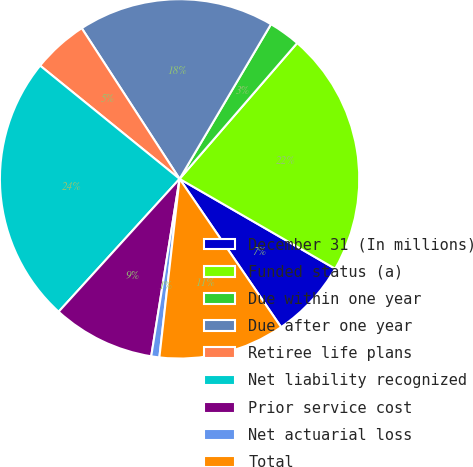<chart> <loc_0><loc_0><loc_500><loc_500><pie_chart><fcel>December 31 (In millions)<fcel>Funded status (a)<fcel>Due within one year<fcel>Due after one year<fcel>Retiree life plans<fcel>Net liability recognized<fcel>Prior service cost<fcel>Net actuarial loss<fcel>Total<nl><fcel>7.11%<fcel>21.98%<fcel>2.86%<fcel>17.66%<fcel>4.98%<fcel>24.1%<fcel>9.23%<fcel>0.73%<fcel>11.35%<nl></chart> 